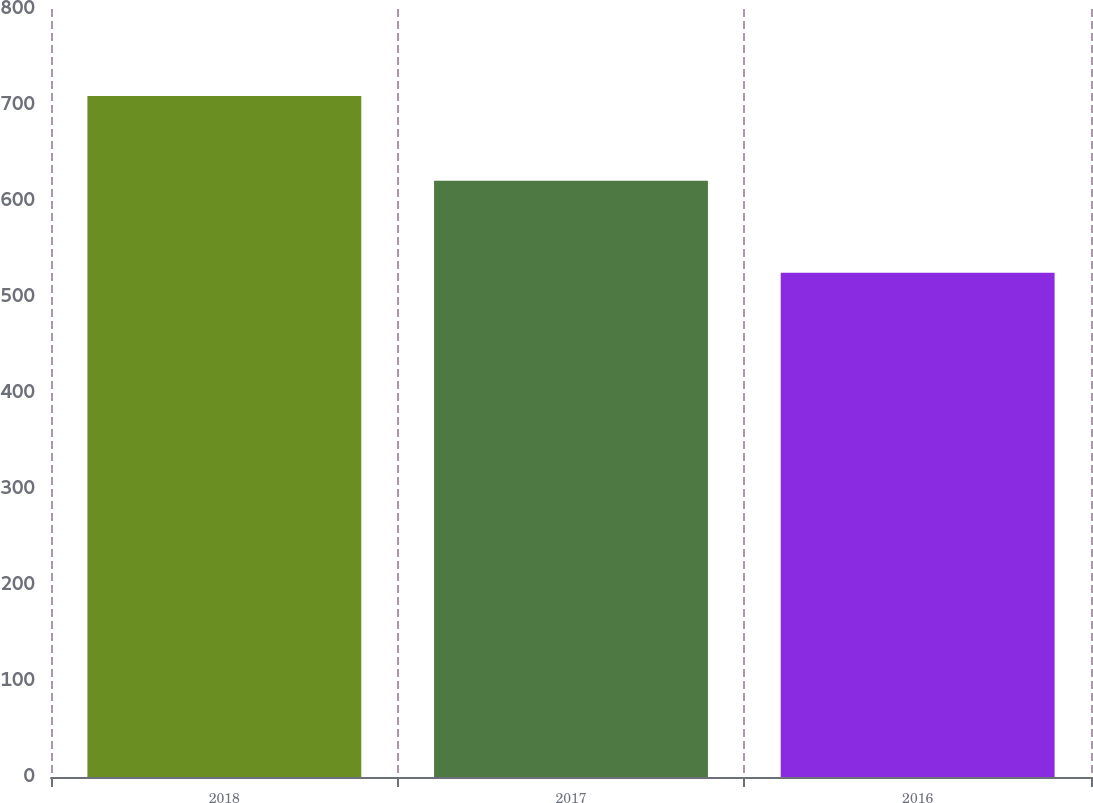<chart> <loc_0><loc_0><loc_500><loc_500><bar_chart><fcel>2018<fcel>2017<fcel>2016<nl><fcel>709.5<fcel>621.1<fcel>525.2<nl></chart> 